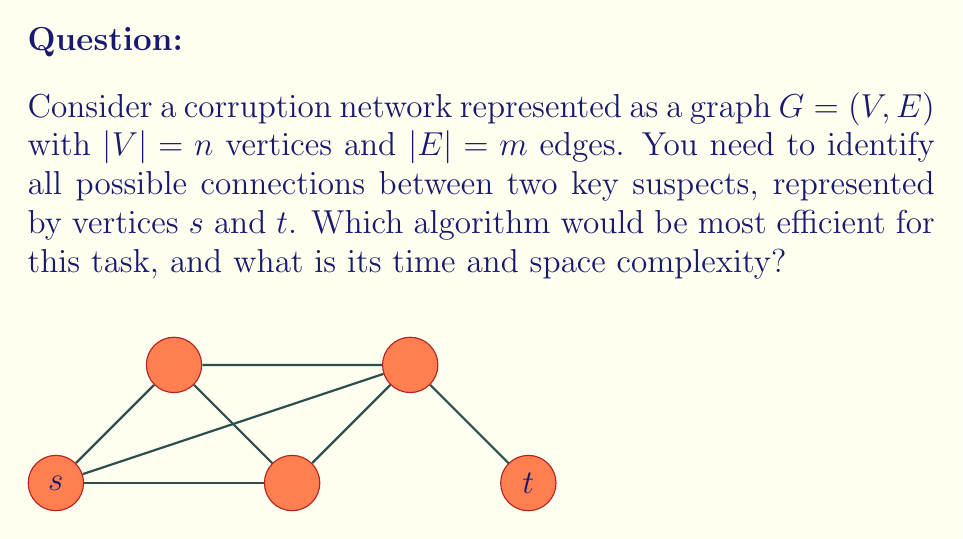Help me with this question. To identify all possible connections between two vertices in a graph, we need to find all simple paths between them. This problem is known as the "All Simple Paths" problem.

1. The most efficient algorithm for this task is a modified Depth-First Search (DFS).

2. Time Complexity Analysis:
   - In the worst case, the graph could be complete, and all paths from $s$ to $t$ might need to be explored.
   - The number of simple paths in a complete graph can be up to $O(n!)$.
   - Each path can have at most $n-1$ edges.
   - Therefore, the time complexity is $O(n \cdot n!)$.

3. Space Complexity Analysis:
   - The DFS recursion stack can go up to depth $n$.
   - We need to store the current path, which can be up to length $n$.
   - Therefore, the space complexity is $O(n)$.

4. Optimizations:
   - Pruning: Stop exploration when the path length exceeds $n-1$.
   - Early termination: If a specific number of paths is required, stop after finding them.

5. Alternative Approaches:
   - For dense graphs, matrix multiplication methods like the Floyd-Warshall algorithm can be used to find the transitive closure, but this doesn't directly give all simple paths.

6. Practical Considerations:
   - In real-world corruption networks, the graph is likely to be sparse, making the average-case performance much better than the worst-case.
   - Heuristics based on domain knowledge (e.g., maximum path length, trusted intermediaries) can significantly reduce the search space.
Answer: Modified DFS; Time: $O(n \cdot n!)$, Space: $O(n)$ 